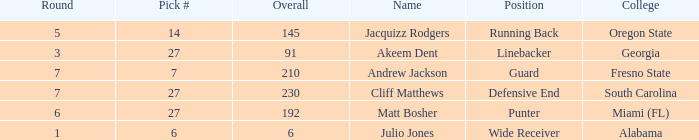Which highest pick number had Akeem Dent as a name and where the overall was less than 91? None. 